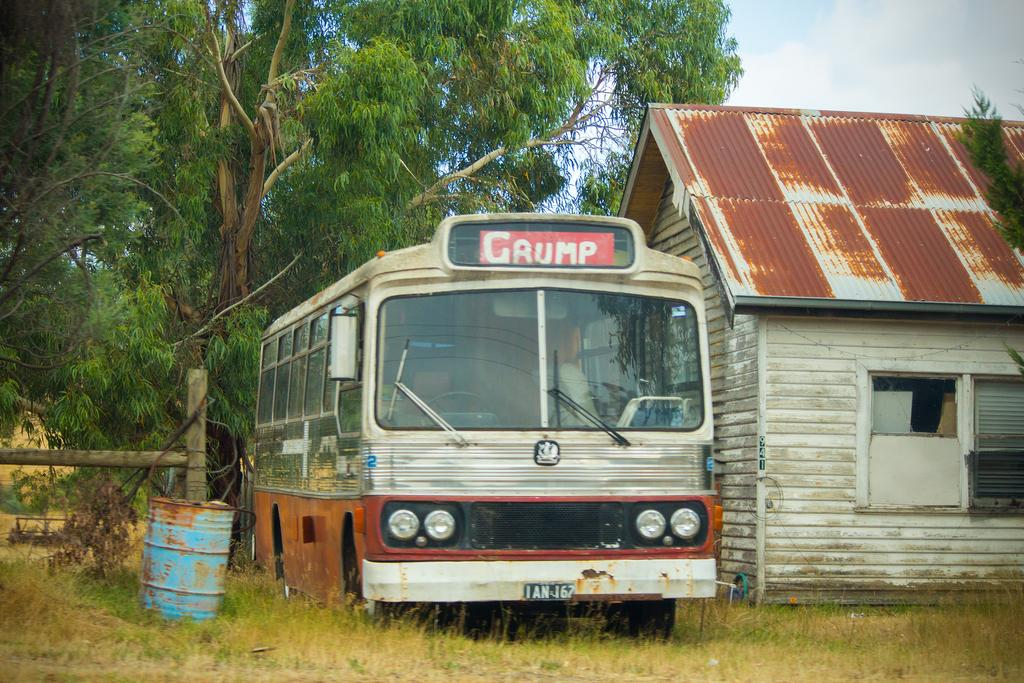<image>
Render a clear and concise summary of the photo. an old bus that says Gaump is sitting by an old building 